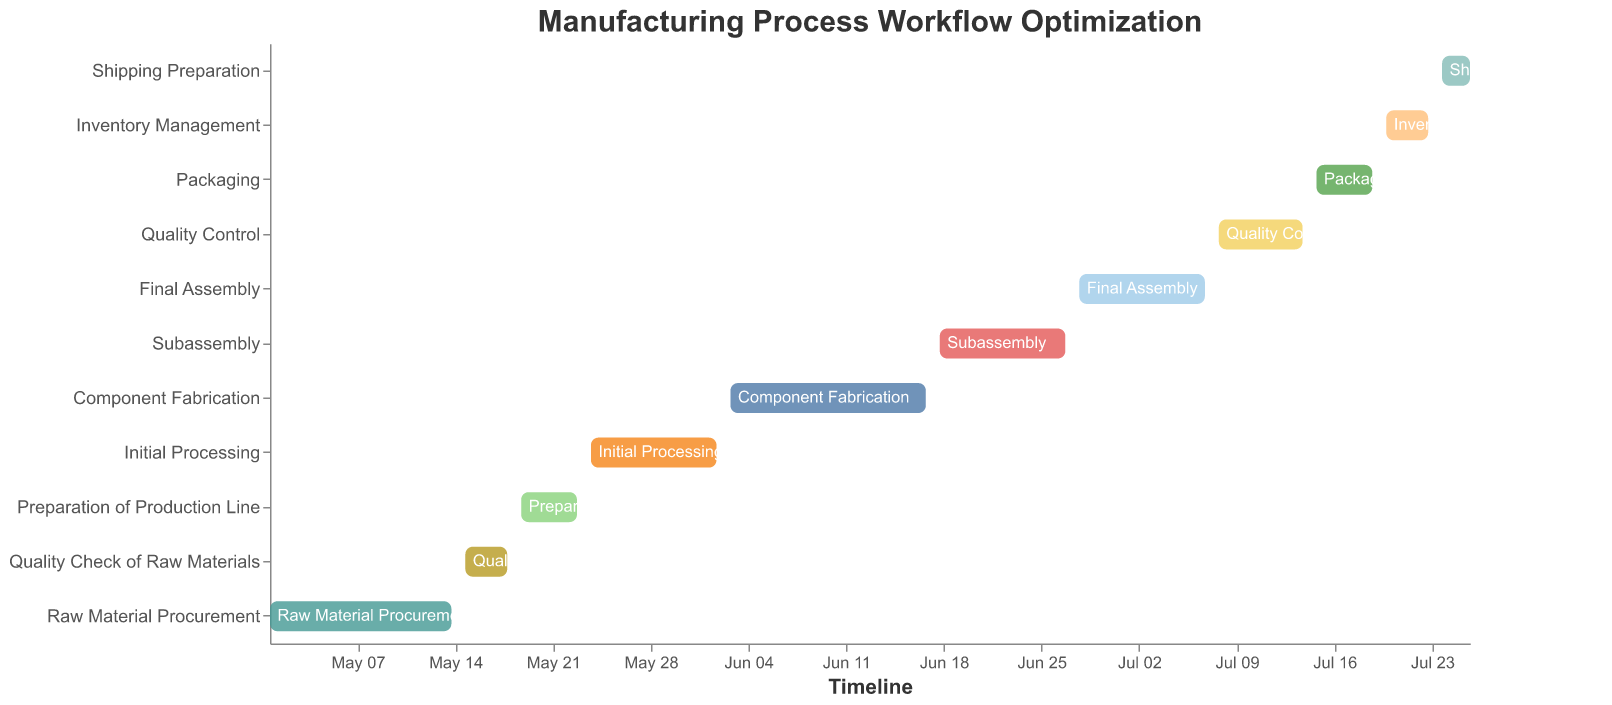What's the title of the figure? The title is located at the top of the figure and indicates the subject of the Gantt Chart.
Answer: Manufacturing Process Workflow Optimization What task takes the longest to complete? By comparing the duration of each task listed in the dataset, Component Fabrication has the longest duration with 15 days.
Answer: Component Fabrication Which tasks happen in the month of June? The tasks falling in the month of June (from 03 to 30) are Initial Processing, Component Fabrication, and Subassembly.
Answer: Initial Processing, Component Fabrication, Subassembly What is the total duration from Raw Material Procurement to Shipping Preparation? Summing the duration of all tasks: 14 + 4 + 5 + 10 + 15 + 10 + 10 + 7 + 5 + 4 + 3 = 87 days.
Answer: 87 days Which tasks immediately follow the 'Preparation of Production Line'? The task that comes immediately after 'Preparation of Production Line' in the timeline is 'Initial Processing'.
Answer: Initial Processing How does the duration of 'Final Assembly' compare with 'Subassembly'? Comparing the duration of both tasks, 'Final Assembly' takes 10 days, while 'Subassembly' also takes 10 days. Therefore, both tasks have the same duration.
Answer: They have the same duration Are there any tasks that overlap in time? By examining the start and end dates, 'Initial Processing' overlaps with 'Component Fabrication' and 'Component Fabrication' overlaps with 'Subassembly'.
Answer: Yes, Initial Processing and Component Fabrication, Component Fabrication and Subassembly When does the 'Quality Control' task start and end? According to the dataset, 'Quality Control' starts on 2023-07-08 and ends on 2023-07-14.
Answer: July 8 to July 14 Is 'Packaging' the final task in the workflow? No, the final task based on the chronological order in the Gantt Chart is 'Shipping Preparation'.
Answer: No Which task has the shortest duration and how long is it? By comparing the duration of each task, 'Shipping Preparation' has the shortest duration with 3 days.
Answer: Shipping Preparation, 3 days 